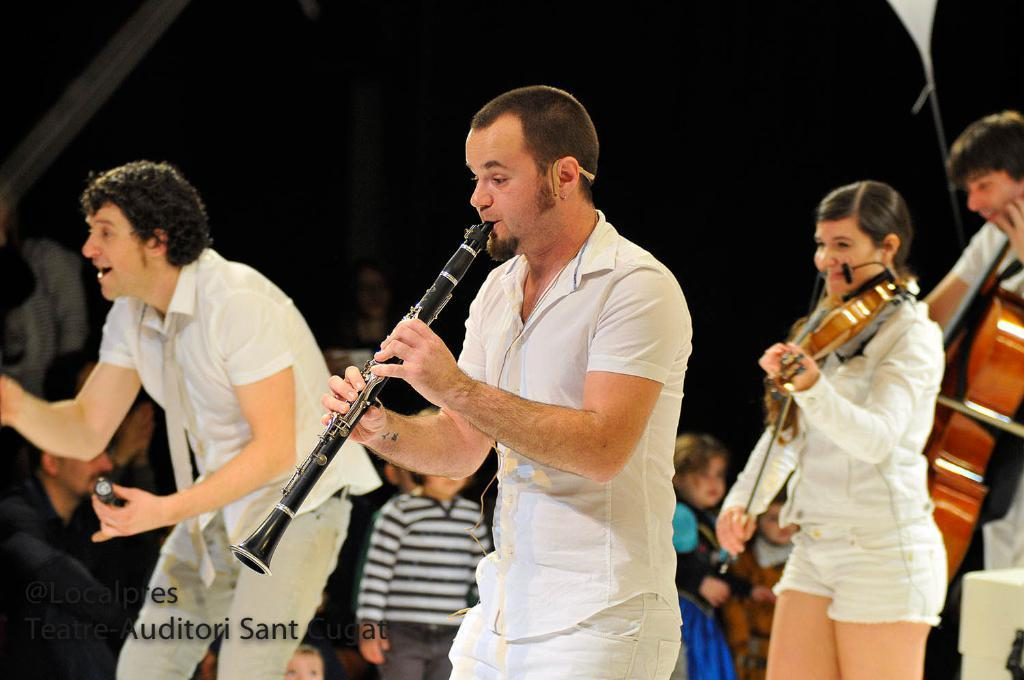How many people are in the image? There are three persons in the image. What are the three persons doing? They are playing musical instruments. Can you describe the person holding a microphone? One person is holding a microphone. What are the positions of the other two persons? The other two persons are standing. What type of clam can be seen playing a guitar in the image? There is no clam present in the image, and therefore no such activity can be observed. 